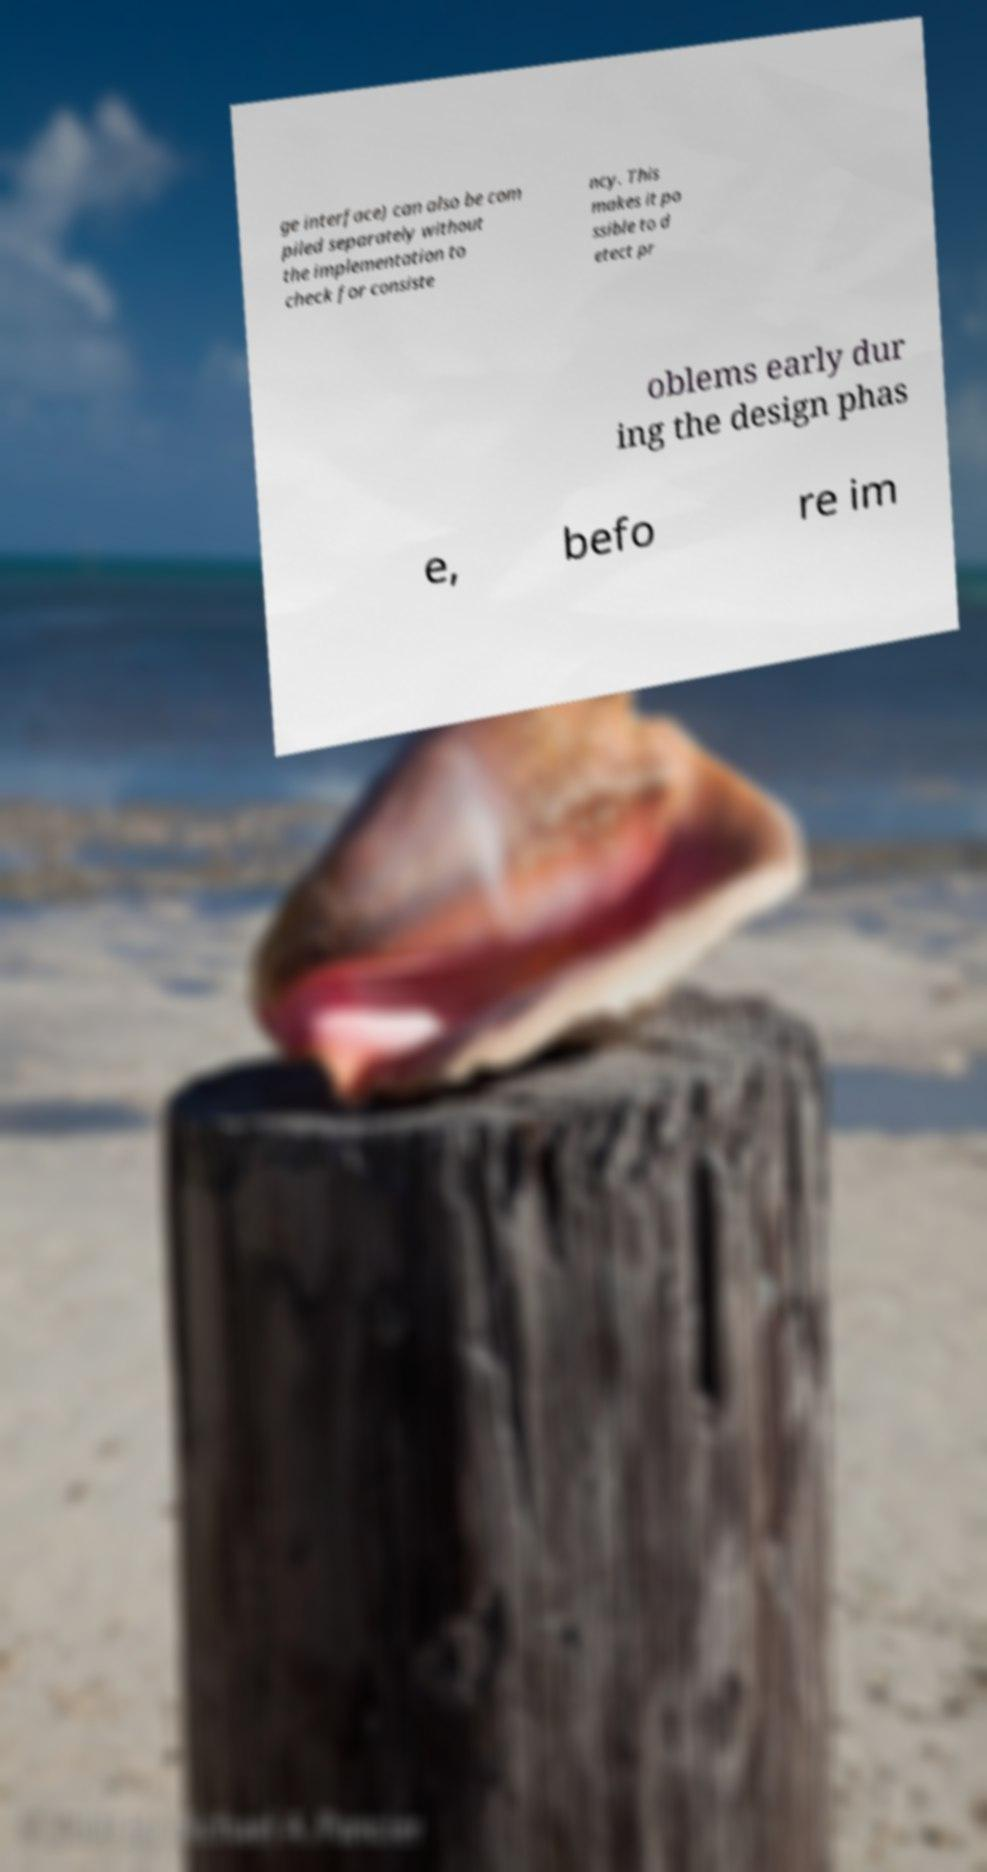There's text embedded in this image that I need extracted. Can you transcribe it verbatim? ge interface) can also be com piled separately without the implementation to check for consiste ncy. This makes it po ssible to d etect pr oblems early dur ing the design phas e, befo re im 